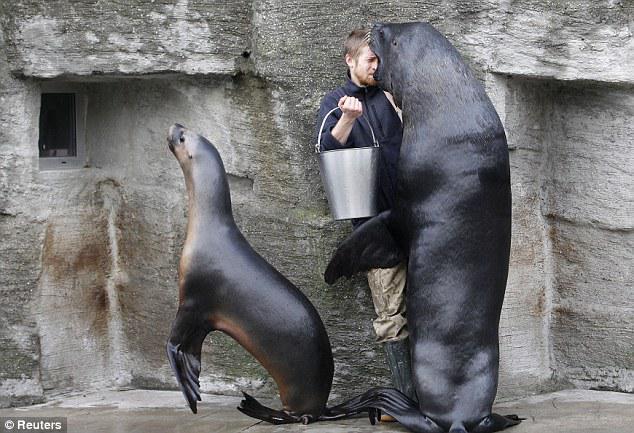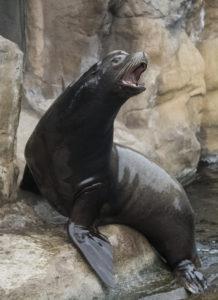The first image is the image on the left, the second image is the image on the right. Considering the images on both sides, is "A man is interacting with one of the seals." valid? Answer yes or no. Yes. The first image is the image on the left, the second image is the image on the right. For the images shown, is this caption "There is one trainer working with a seal in the image on the left." true? Answer yes or no. Yes. 